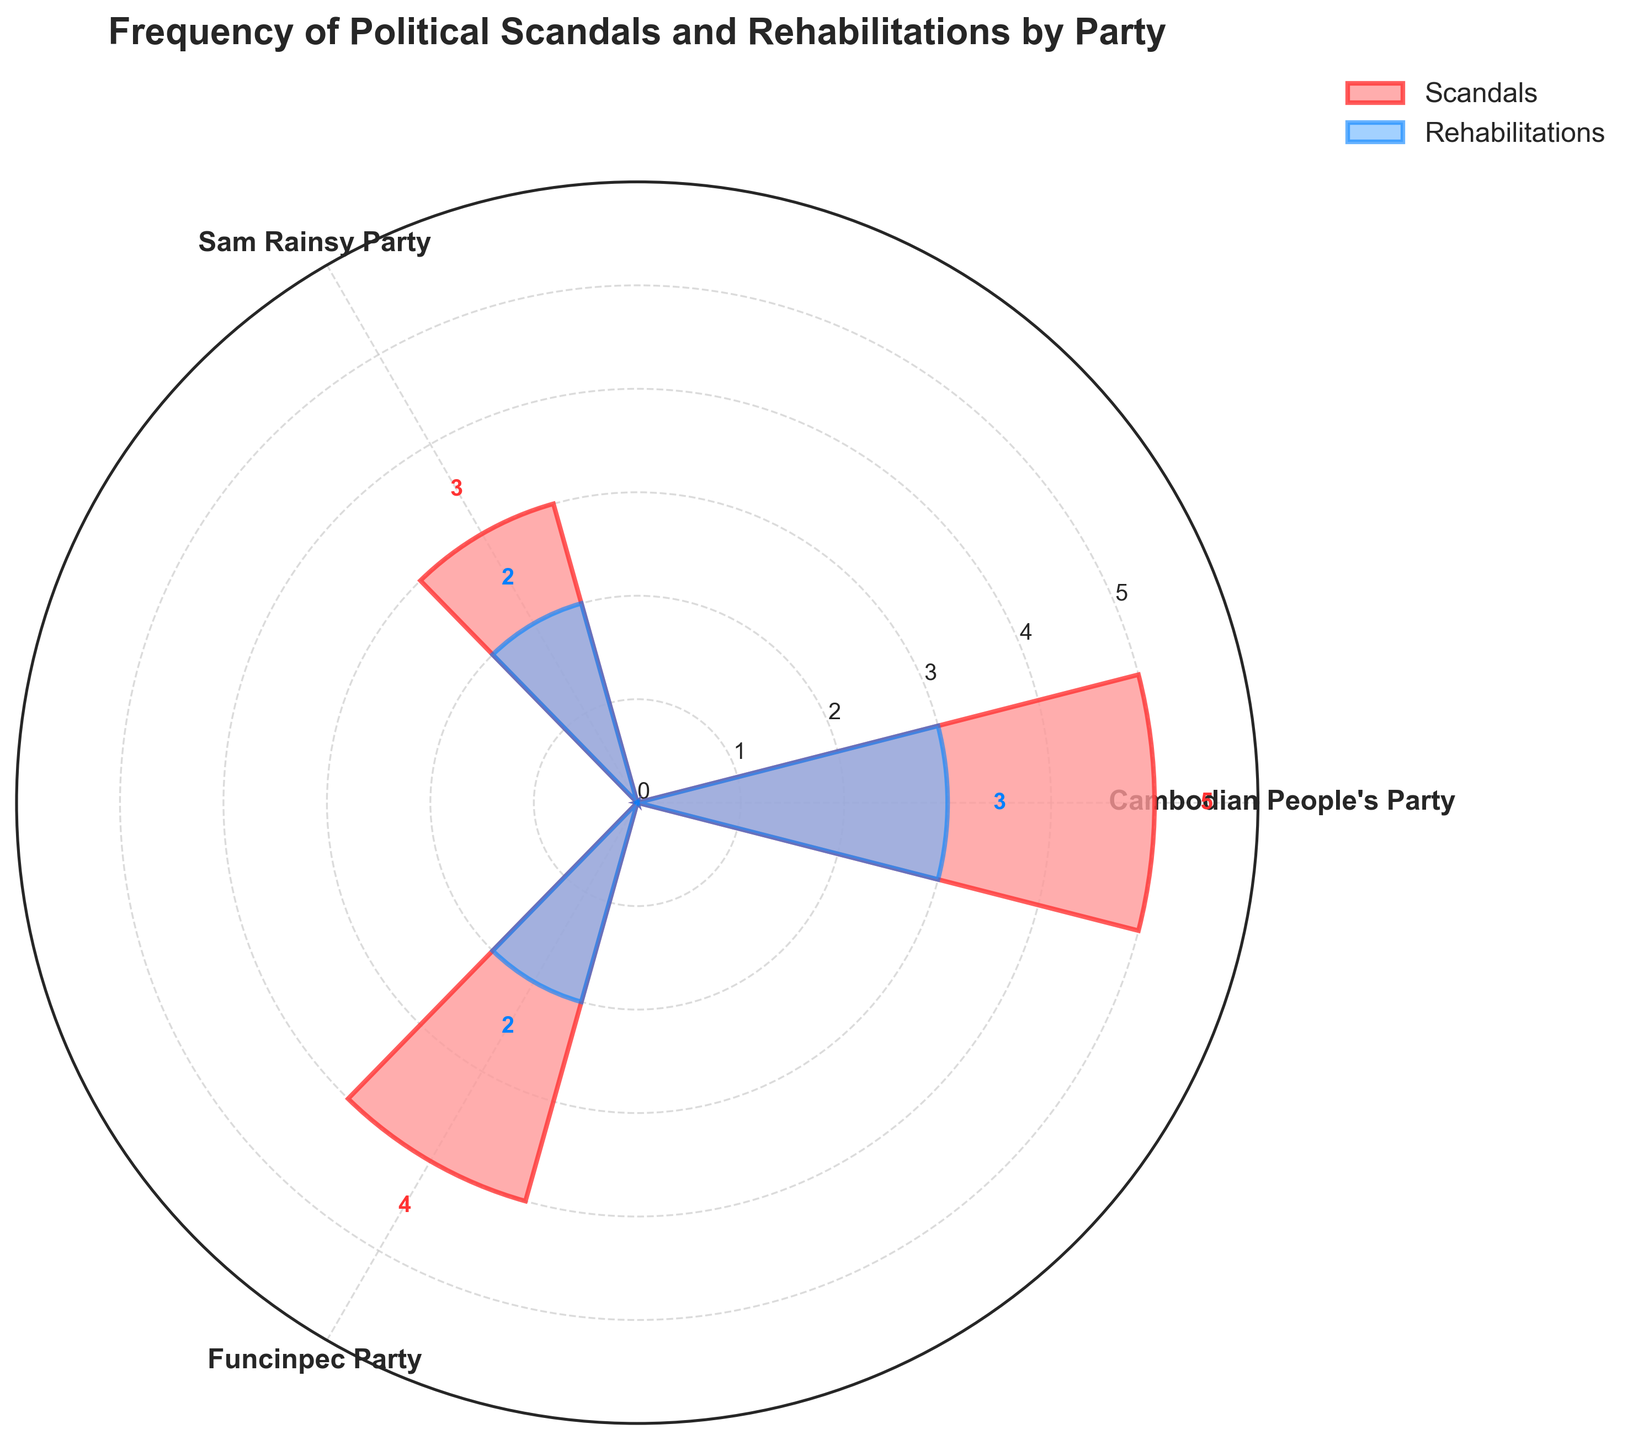What's the title of the figure? The title is displayed at the top of the figure in a larger, bold font.
Answer: Frequency of Political Scandals and Rehabilitations by Party Which political party has the highest number of scandals? The bars in the rose chart represent the number of scandals per party. Identify the tallest bar.
Answer: Cambodian People's Party Which political party has an equal number of scandals and rehabilitations? Examine the heights of the bars for each party in both scandals and rehabilitations.
Answer: None Summarize the frequency of scandals for all three parties combined. Add the values representing the frequency of scandals for each party: 5 (Cambodian People's Party) + 3 (Sam Rainsy Party) + 4 (Funcinpec Party) = 12.
Answer: 12 How does the frequency of rehabilitations for the Cambodian People's Party compare to the Funcinpec Party? Compare the height of the rehabilitations bar for both the Cambodian People's Party (3) and the Funcinpec Party (2).
Answer: Cambodian People's Party has more rehabilitations Calculate the average frequency of rehabilitations per party. Sum the frequency of rehabilitations for all parties (3 + 2 + 2) and divide by the number of parties (3): (3 + 2 + 2) / 3 ≈ 2.33.
Answer: 2.33 Which party has the lowest number of rehabilitations? Identify the smallest value in the rehabilitations data points.
Answer: Sam Rainsy Party and Funcinpec Party (tie) What is the combined total of scandals and rehabilitations for the Funcinpec Party? Add the values for scandals and rehabilitations for the Funcinpec Party: 4 (scandals) + 2 (rehabilitations) = 6.
Answer: 6 